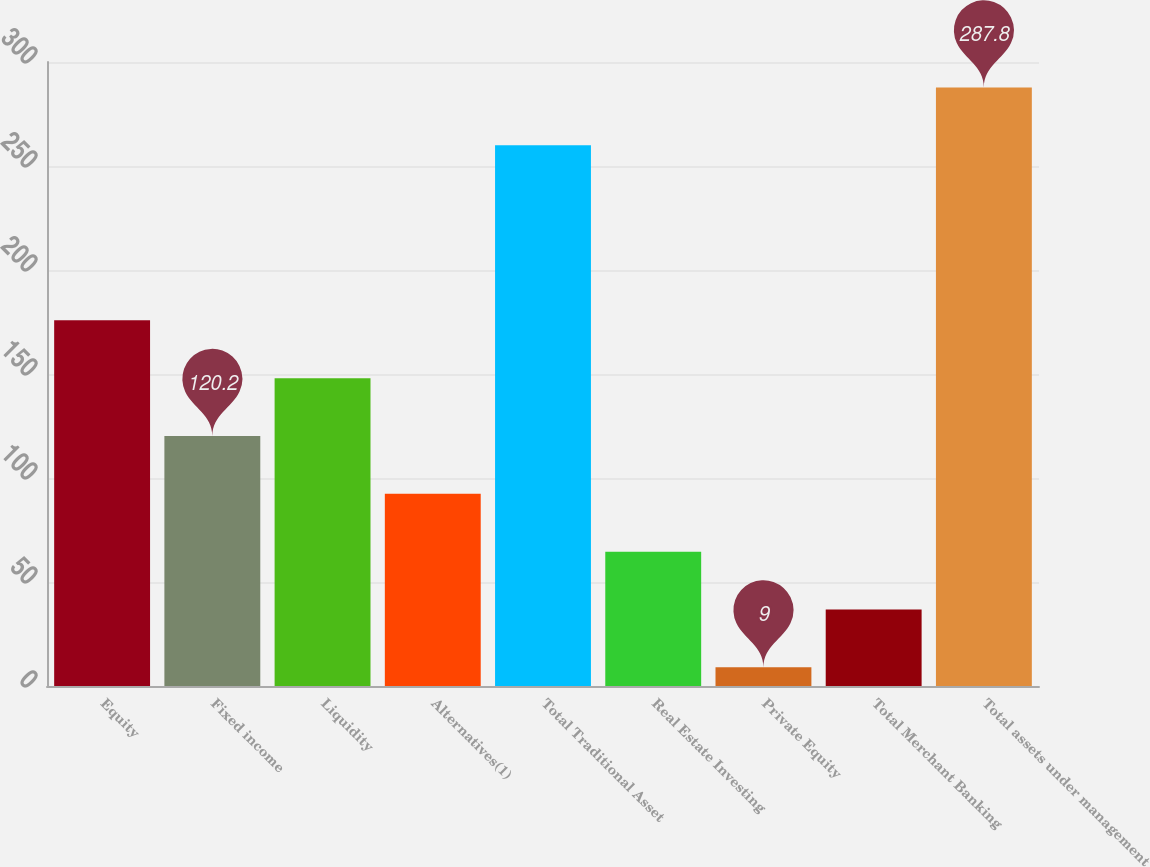Convert chart to OTSL. <chart><loc_0><loc_0><loc_500><loc_500><bar_chart><fcel>Equity<fcel>Fixed income<fcel>Liquidity<fcel>Alternatives(1)<fcel>Total Traditional Asset<fcel>Real Estate Investing<fcel>Private Equity<fcel>Total Merchant Banking<fcel>Total assets under management<nl><fcel>175.8<fcel>120.2<fcel>148<fcel>92.4<fcel>260<fcel>64.6<fcel>9<fcel>36.8<fcel>287.8<nl></chart> 